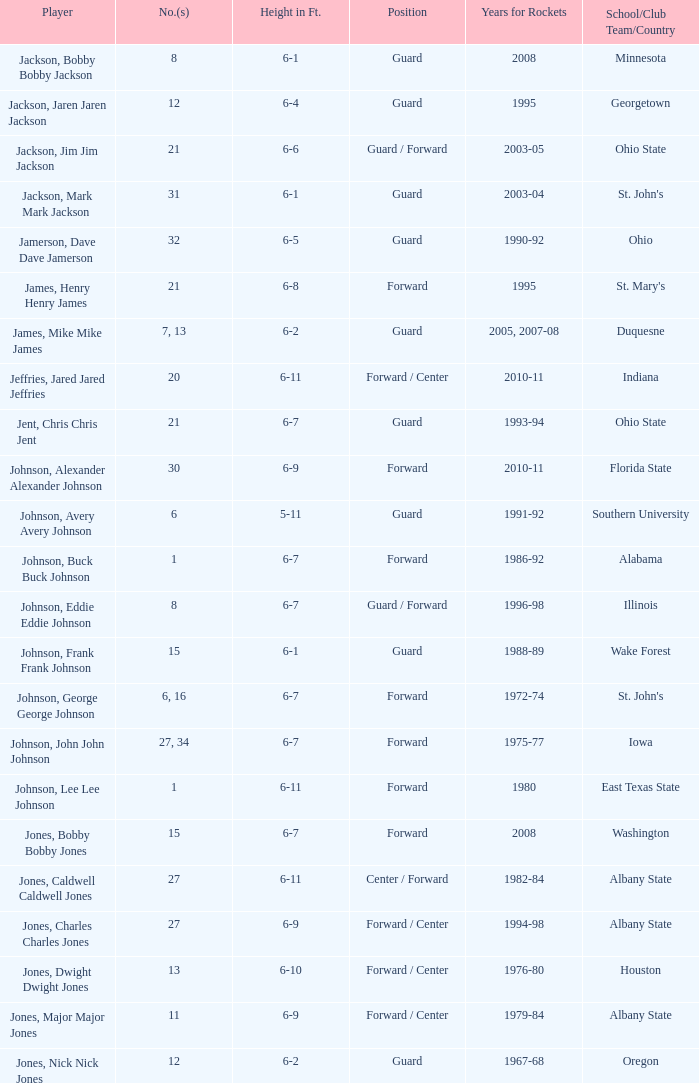Write the full table. {'header': ['Player', 'No.(s)', 'Height in Ft.', 'Position', 'Years for Rockets', 'School/Club Team/Country'], 'rows': [['Jackson, Bobby Bobby Jackson', '8', '6-1', 'Guard', '2008', 'Minnesota'], ['Jackson, Jaren Jaren Jackson', '12', '6-4', 'Guard', '1995', 'Georgetown'], ['Jackson, Jim Jim Jackson', '21', '6-6', 'Guard / Forward', '2003-05', 'Ohio State'], ['Jackson, Mark Mark Jackson', '31', '6-1', 'Guard', '2003-04', "St. John's"], ['Jamerson, Dave Dave Jamerson', '32', '6-5', 'Guard', '1990-92', 'Ohio'], ['James, Henry Henry James', '21', '6-8', 'Forward', '1995', "St. Mary's"], ['James, Mike Mike James', '7, 13', '6-2', 'Guard', '2005, 2007-08', 'Duquesne'], ['Jeffries, Jared Jared Jeffries', '20', '6-11', 'Forward / Center', '2010-11', 'Indiana'], ['Jent, Chris Chris Jent', '21', '6-7', 'Guard', '1993-94', 'Ohio State'], ['Johnson, Alexander Alexander Johnson', '30', '6-9', 'Forward', '2010-11', 'Florida State'], ['Johnson, Avery Avery Johnson', '6', '5-11', 'Guard', '1991-92', 'Southern University'], ['Johnson, Buck Buck Johnson', '1', '6-7', 'Forward', '1986-92', 'Alabama'], ['Johnson, Eddie Eddie Johnson', '8', '6-7', 'Guard / Forward', '1996-98', 'Illinois'], ['Johnson, Frank Frank Johnson', '15', '6-1', 'Guard', '1988-89', 'Wake Forest'], ['Johnson, George George Johnson', '6, 16', '6-7', 'Forward', '1972-74', "St. John's"], ['Johnson, John John Johnson', '27, 34', '6-7', 'Forward', '1975-77', 'Iowa'], ['Johnson, Lee Lee Johnson', '1', '6-11', 'Forward', '1980', 'East Texas State'], ['Jones, Bobby Bobby Jones', '15', '6-7', 'Forward', '2008', 'Washington'], ['Jones, Caldwell Caldwell Jones', '27', '6-11', 'Center / Forward', '1982-84', 'Albany State'], ['Jones, Charles Charles Jones', '27', '6-9', 'Forward / Center', '1994-98', 'Albany State'], ['Jones, Dwight Dwight Jones', '13', '6-10', 'Forward / Center', '1976-80', 'Houston'], ['Jones, Major Major Jones', '11', '6-9', 'Forward / Center', '1979-84', 'Albany State'], ['Jones, Nick Nick Jones', '12', '6-2', 'Guard', '1967-68', 'Oregon']]} Which player who played for the Rockets for the years 1986-92? Johnson, Buck Buck Johnson. 